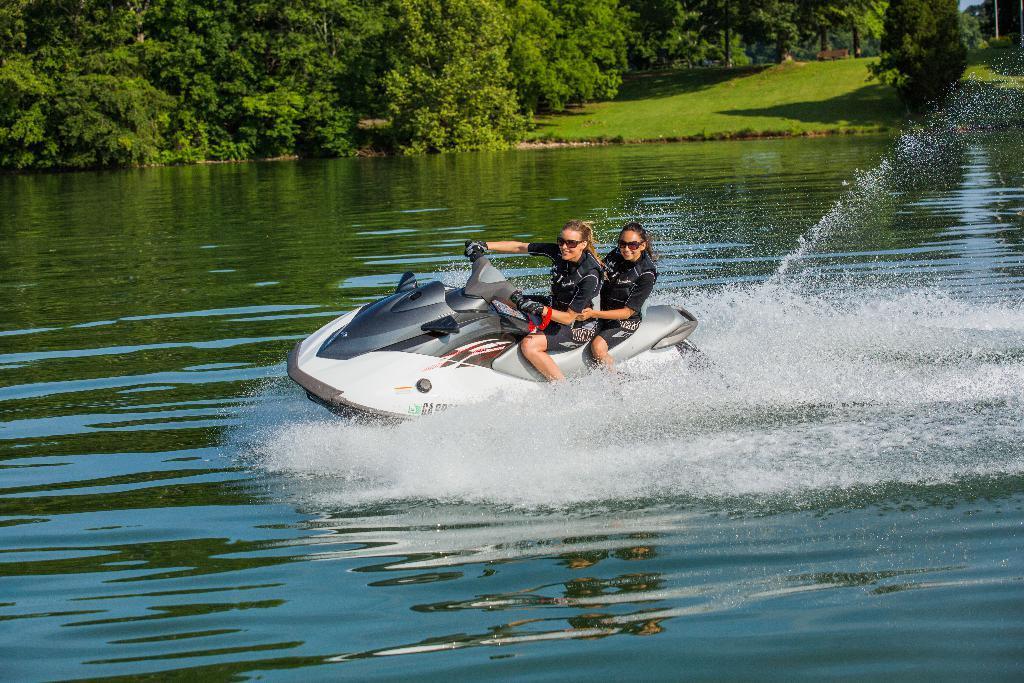Describe this image in one or two sentences. In this image we can see two women are doing jet ski. Background trees are there and the land is full of grass. 